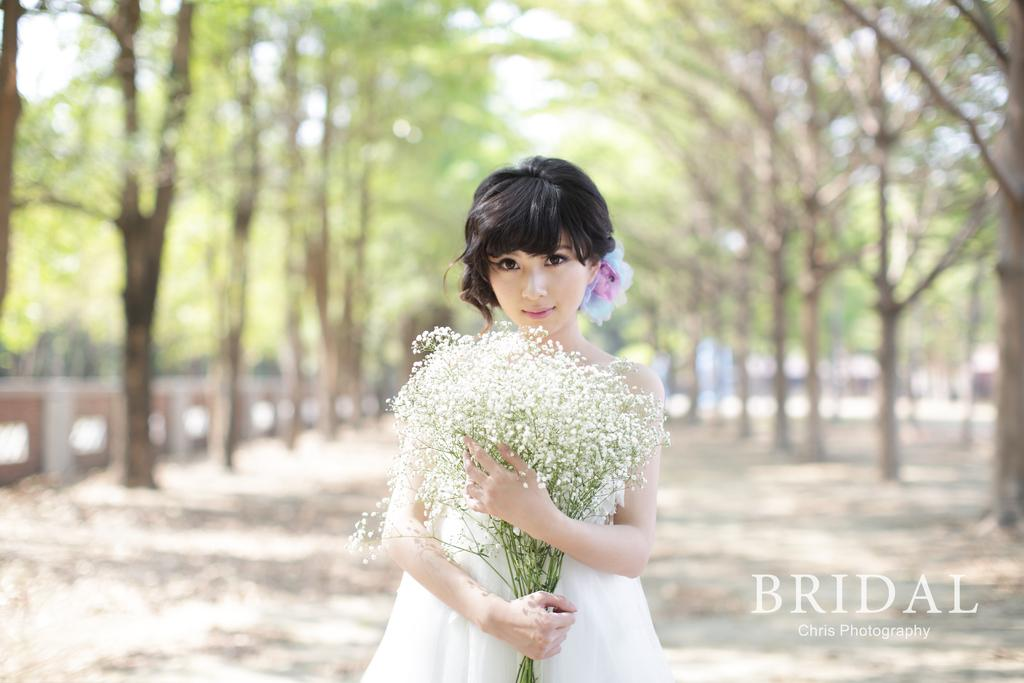What is the main subject of the image? There is a beautiful woman in the image. What is the woman holding in the image? The woman is holding flowers. What is the woman wearing in the image? The woman is wearing a white dress. What can be seen in the background of the image? There are trees on either side of the image. Is there any additional detail visible on the image? Yes, there is a water mark on the right side of the image. What type of salt is sprinkled on the ground in the image? There is no salt or ground present in the image; it features a woman holding flowers and wearing a white dress, with trees in the background and a water mark on the right side. 